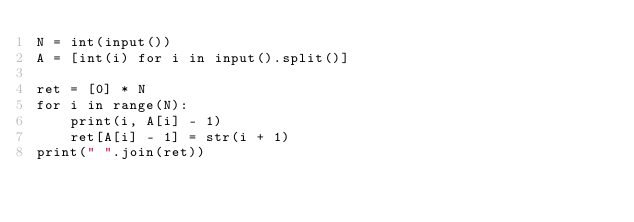Convert code to text. <code><loc_0><loc_0><loc_500><loc_500><_Python_>N = int(input())
A = [int(i) for i in input().split()]

ret = [0] * N
for i in range(N):
    print(i, A[i] - 1)
    ret[A[i] - 1] = str(i + 1)
print(" ".join(ret))
</code> 